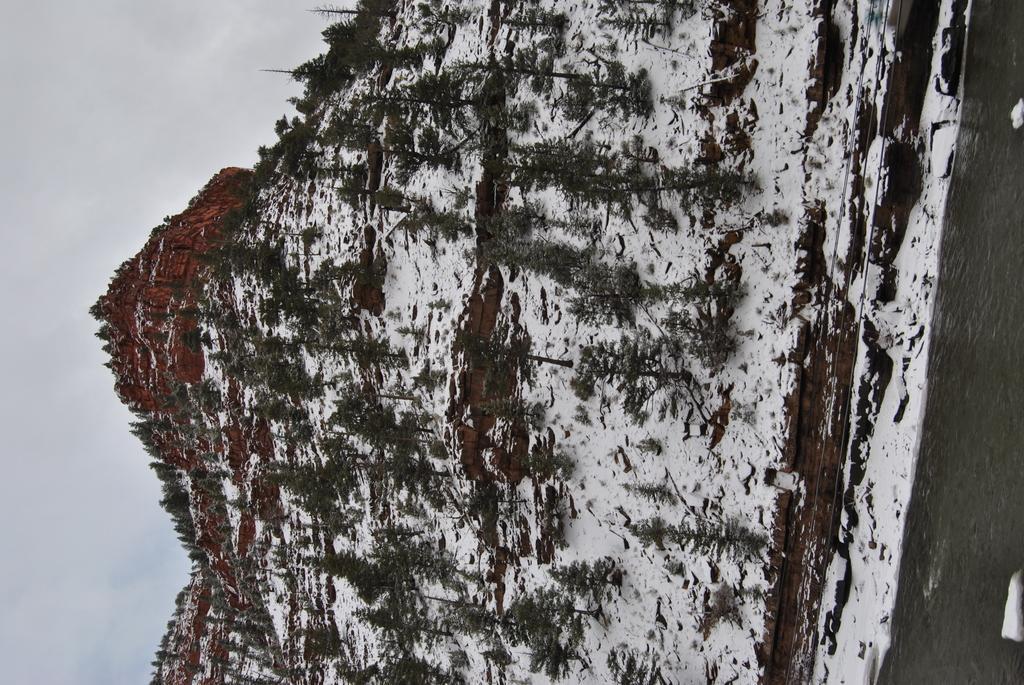Describe this image in one or two sentences. In this picture we can see water, snow, trees and mountain. In the background of the image we can see the sky. 